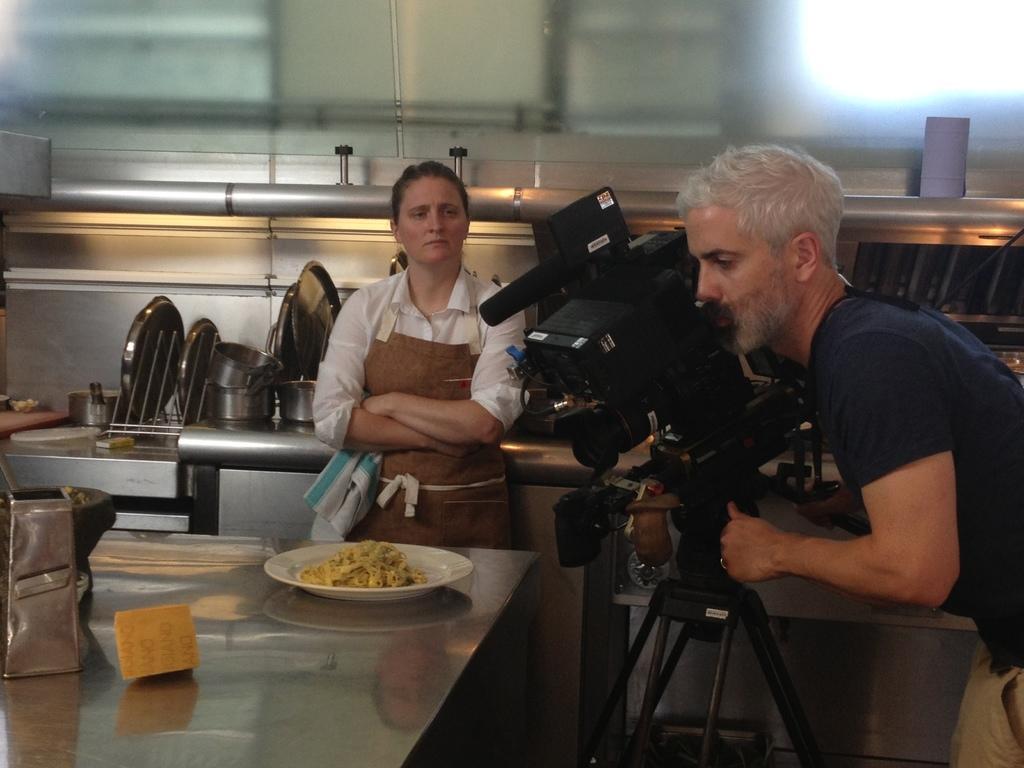In one or two sentences, can you explain what this image depicts? In this picture we can see a camera, two people and in front of them we can see a plate with food on it, some objects on the platform and in the background we can see plates, bowls, pipe, glass and some objects. 